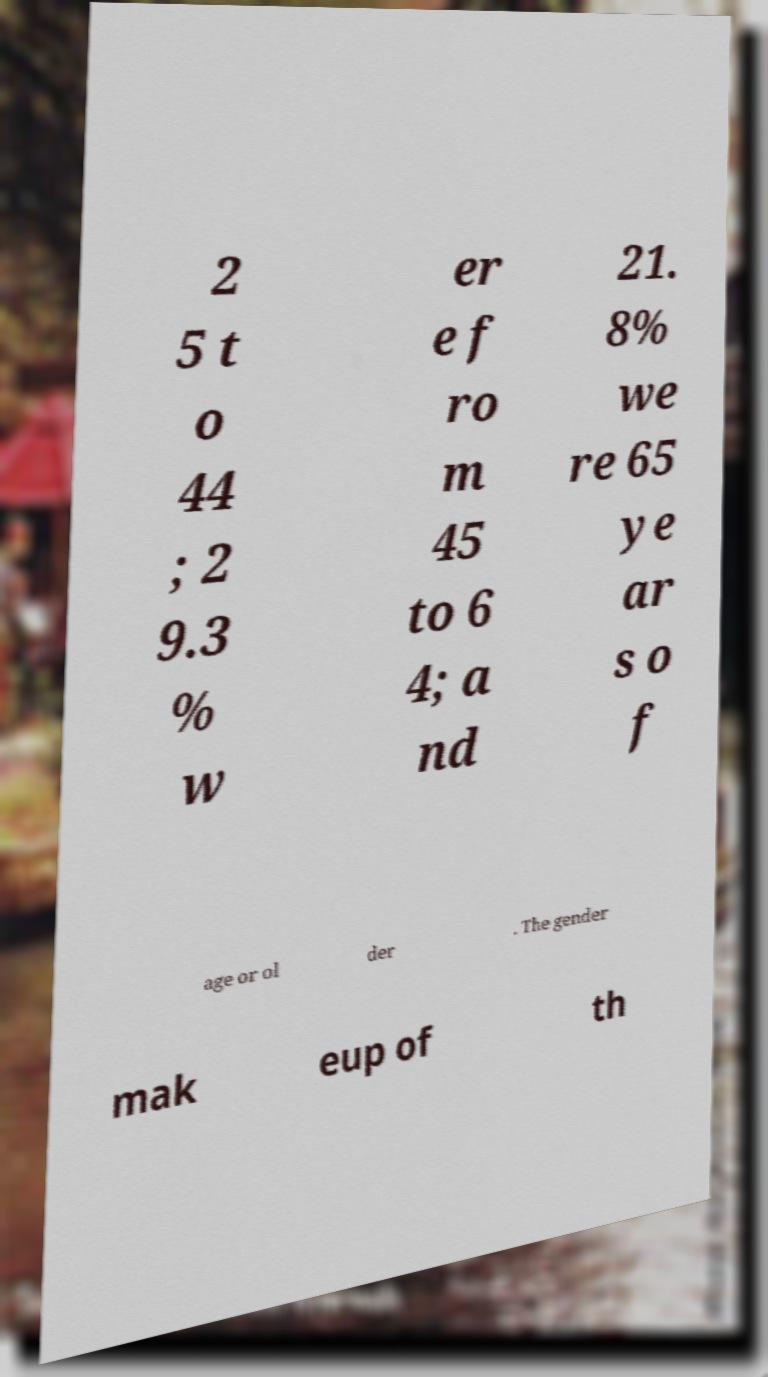Could you extract and type out the text from this image? 2 5 t o 44 ; 2 9.3 % w er e f ro m 45 to 6 4; a nd 21. 8% we re 65 ye ar s o f age or ol der . The gender mak eup of th 